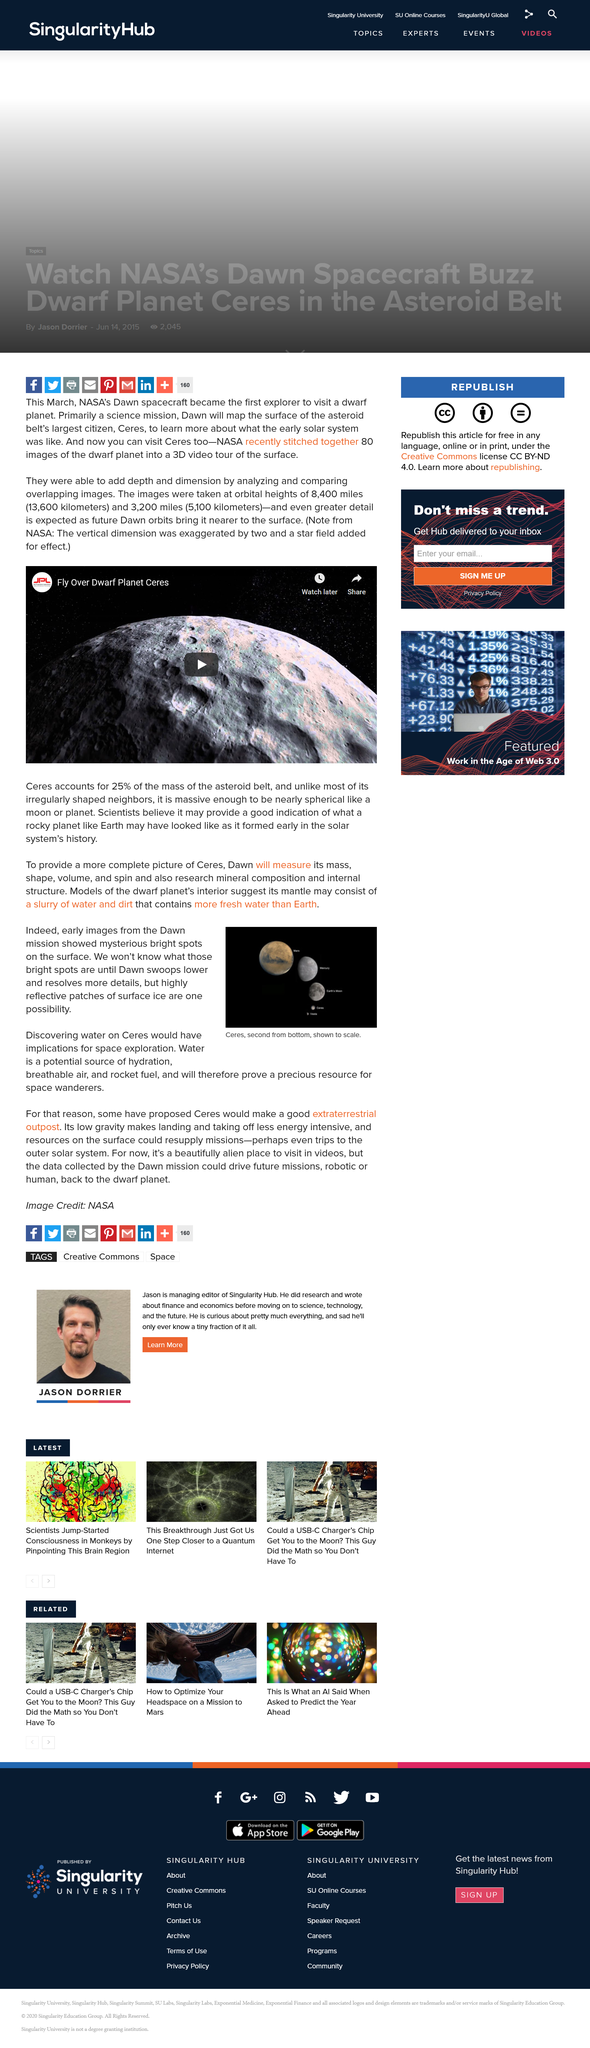Outline some significant characteristics in this image. On Ceres, bright spots on the surface are indicative of the presence of water. Ceres' mass, shape, volume, and spin will be measured by the Dawn spacecraft. The presence of water is suggested by models of Ceres, which is an important substance. 